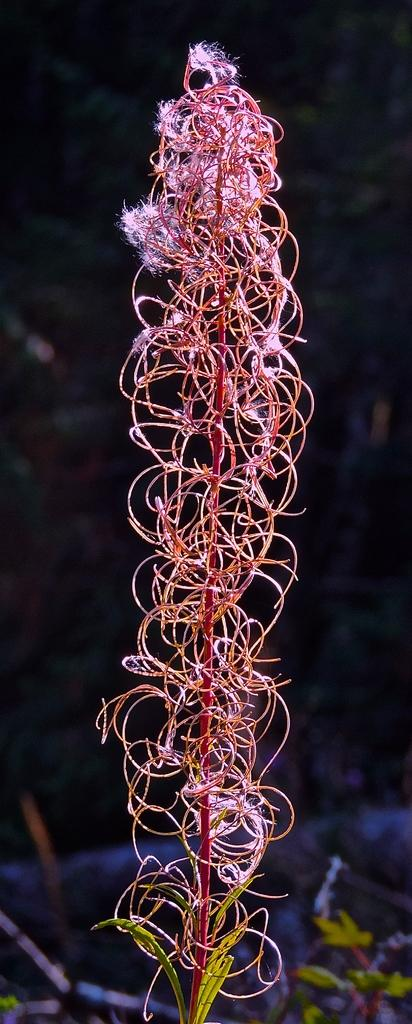What type of plant is featured in the image? There is a plant with pink flowers in the image. Can you describe the other plant visible in the image? There is another plant in the background of the image. How would you characterize the color of the background in the image? The background of the image is dark in color. What advice does the mom give about the grass in the image? There is no mom present in the image, and therefore no advice can be given about the grass. 